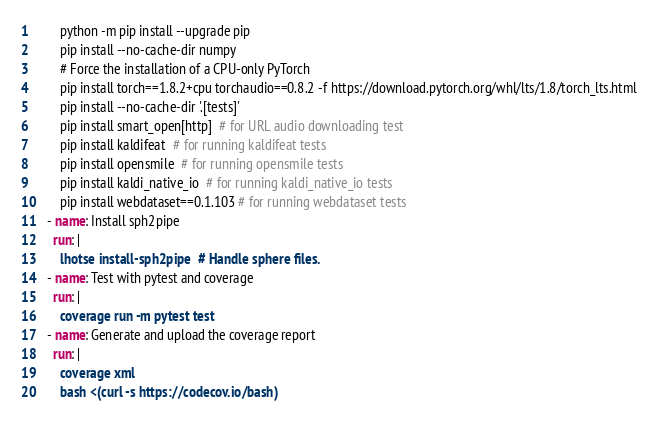<code> <loc_0><loc_0><loc_500><loc_500><_YAML_>        python -m pip install --upgrade pip
        pip install --no-cache-dir numpy
        # Force the installation of a CPU-only PyTorch
        pip install torch==1.8.2+cpu torchaudio==0.8.2 -f https://download.pytorch.org/whl/lts/1.8/torch_lts.html
        pip install --no-cache-dir '.[tests]'
        pip install smart_open[http]  # for URL audio downloading test
        pip install kaldifeat  # for running kaldifeat tests
        pip install opensmile  # for running opensmile tests
        pip install kaldi_native_io  # for running kaldi_native_io tests
        pip install webdataset==0.1.103 # for running webdataset tests
    - name: Install sph2pipe
      run: |
        lhotse install-sph2pipe  # Handle sphere files.
    - name: Test with pytest and coverage
      run: |
        coverage run -m pytest test
    - name: Generate and upload the coverage report
      run: |
        coverage xml
        bash <(curl -s https://codecov.io/bash)
</code> 